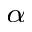Convert formula to latex. <formula><loc_0><loc_0><loc_500><loc_500>_ { \alpha }</formula> 